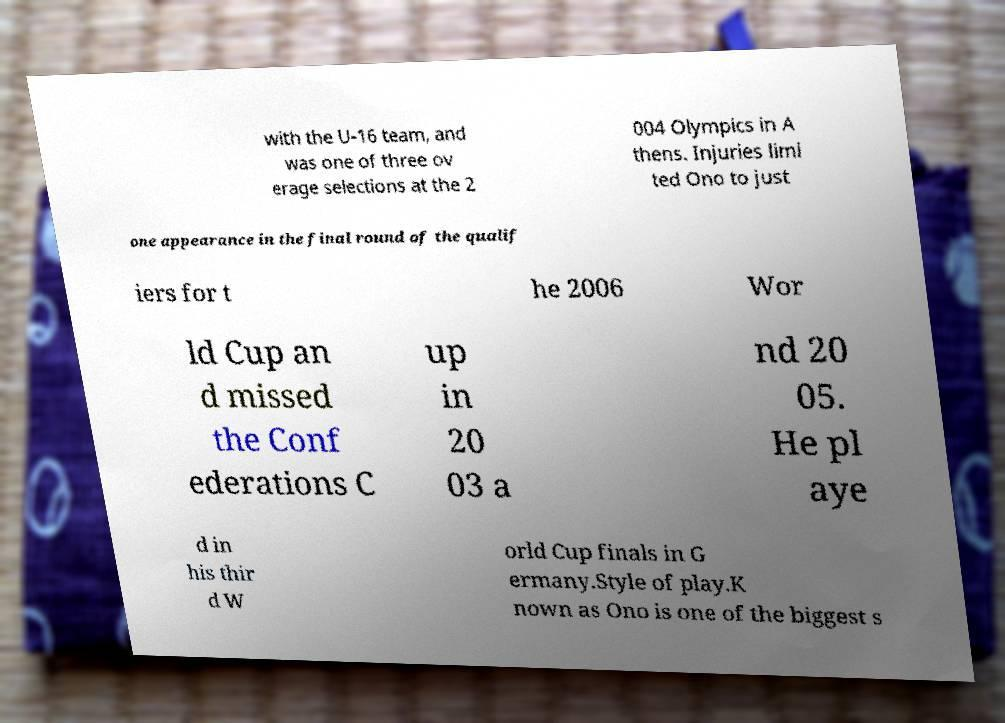Could you extract and type out the text from this image? with the U-16 team, and was one of three ov erage selections at the 2 004 Olympics in A thens. Injuries limi ted Ono to just one appearance in the final round of the qualif iers for t he 2006 Wor ld Cup an d missed the Conf ederations C up in 20 03 a nd 20 05. He pl aye d in his thir d W orld Cup finals in G ermany.Style of play.K nown as Ono is one of the biggest s 